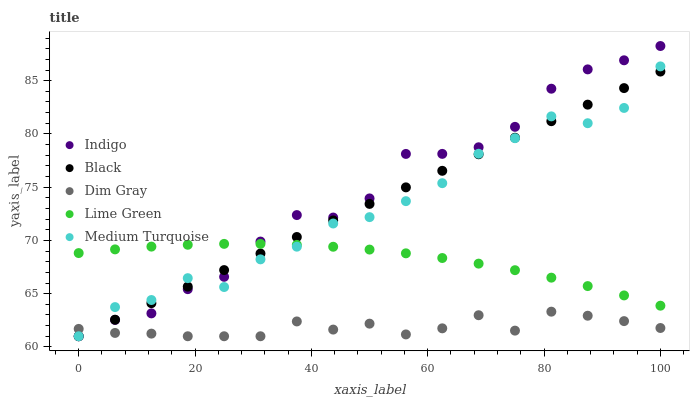Does Dim Gray have the minimum area under the curve?
Answer yes or no. Yes. Does Indigo have the maximum area under the curve?
Answer yes or no. Yes. Does Indigo have the minimum area under the curve?
Answer yes or no. No. Does Dim Gray have the maximum area under the curve?
Answer yes or no. No. Is Black the smoothest?
Answer yes or no. Yes. Is Medium Turquoise the roughest?
Answer yes or no. Yes. Is Dim Gray the smoothest?
Answer yes or no. No. Is Dim Gray the roughest?
Answer yes or no. No. Does Black have the lowest value?
Answer yes or no. Yes. Does Lime Green have the lowest value?
Answer yes or no. No. Does Indigo have the highest value?
Answer yes or no. Yes. Does Dim Gray have the highest value?
Answer yes or no. No. Is Dim Gray less than Lime Green?
Answer yes or no. Yes. Is Lime Green greater than Dim Gray?
Answer yes or no. Yes. Does Black intersect Medium Turquoise?
Answer yes or no. Yes. Is Black less than Medium Turquoise?
Answer yes or no. No. Is Black greater than Medium Turquoise?
Answer yes or no. No. Does Dim Gray intersect Lime Green?
Answer yes or no. No. 